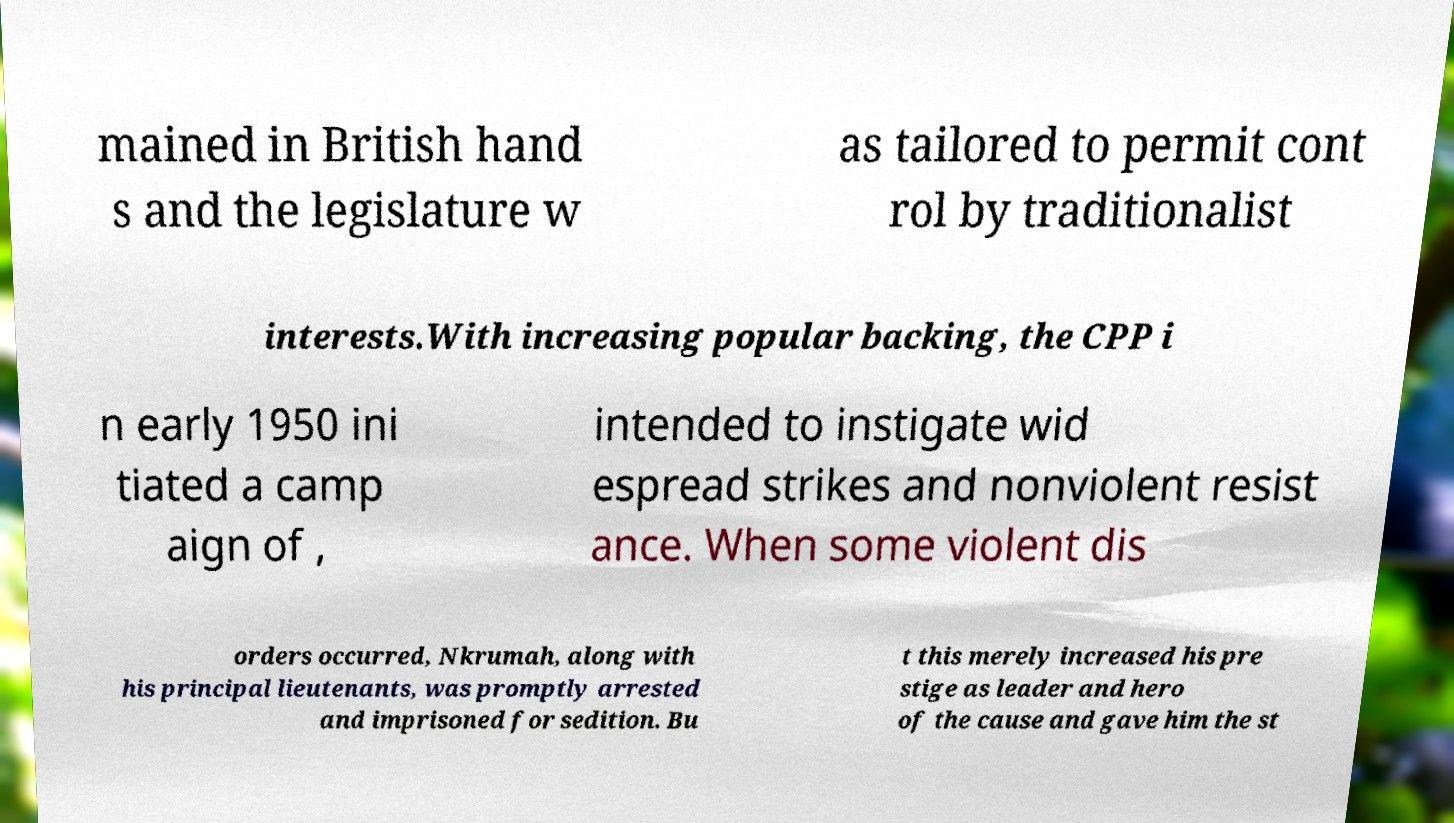For documentation purposes, I need the text within this image transcribed. Could you provide that? mained in British hand s and the legislature w as tailored to permit cont rol by traditionalist interests.With increasing popular backing, the CPP i n early 1950 ini tiated a camp aign of , intended to instigate wid espread strikes and nonviolent resist ance. When some violent dis orders occurred, Nkrumah, along with his principal lieutenants, was promptly arrested and imprisoned for sedition. Bu t this merely increased his pre stige as leader and hero of the cause and gave him the st 